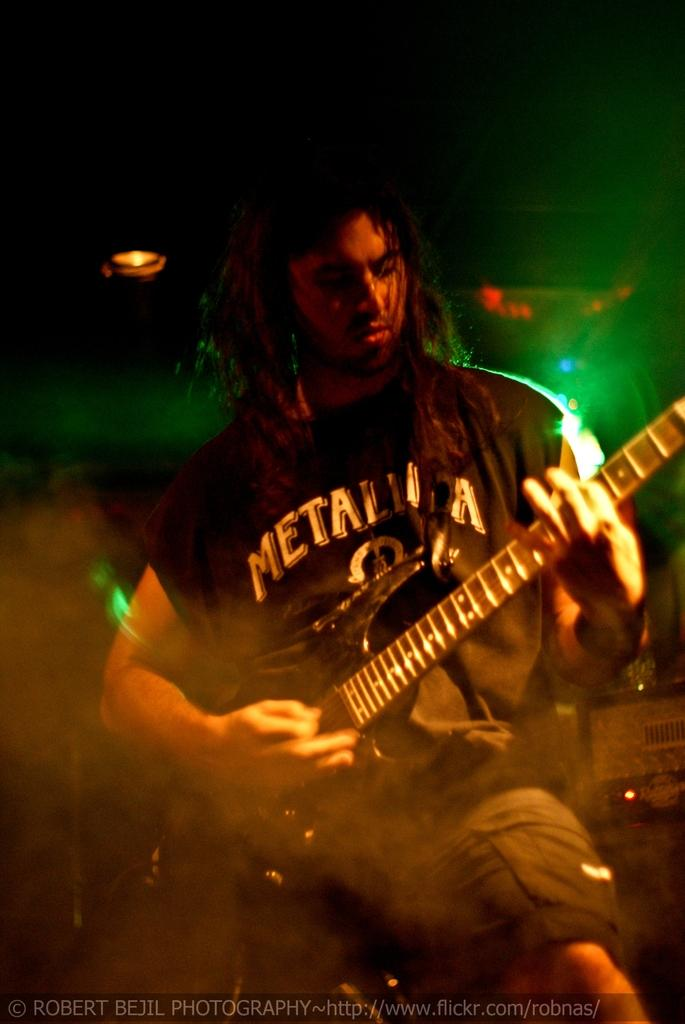Who is the main subject in the image? There is a boy in the image. What is the boy wearing? The boy is wearing a black t-shirt. Can you describe the boy's hair? The boy has long hair. What is the boy doing in the image? The boy is playing a guitar. What can be seen in the background of the image? There is a green and brown light in the background of the image, likely from a studio. Does the boy in the image express any hate towards the audience? There is no indication of the boy expressing hate towards the audience in the image. 